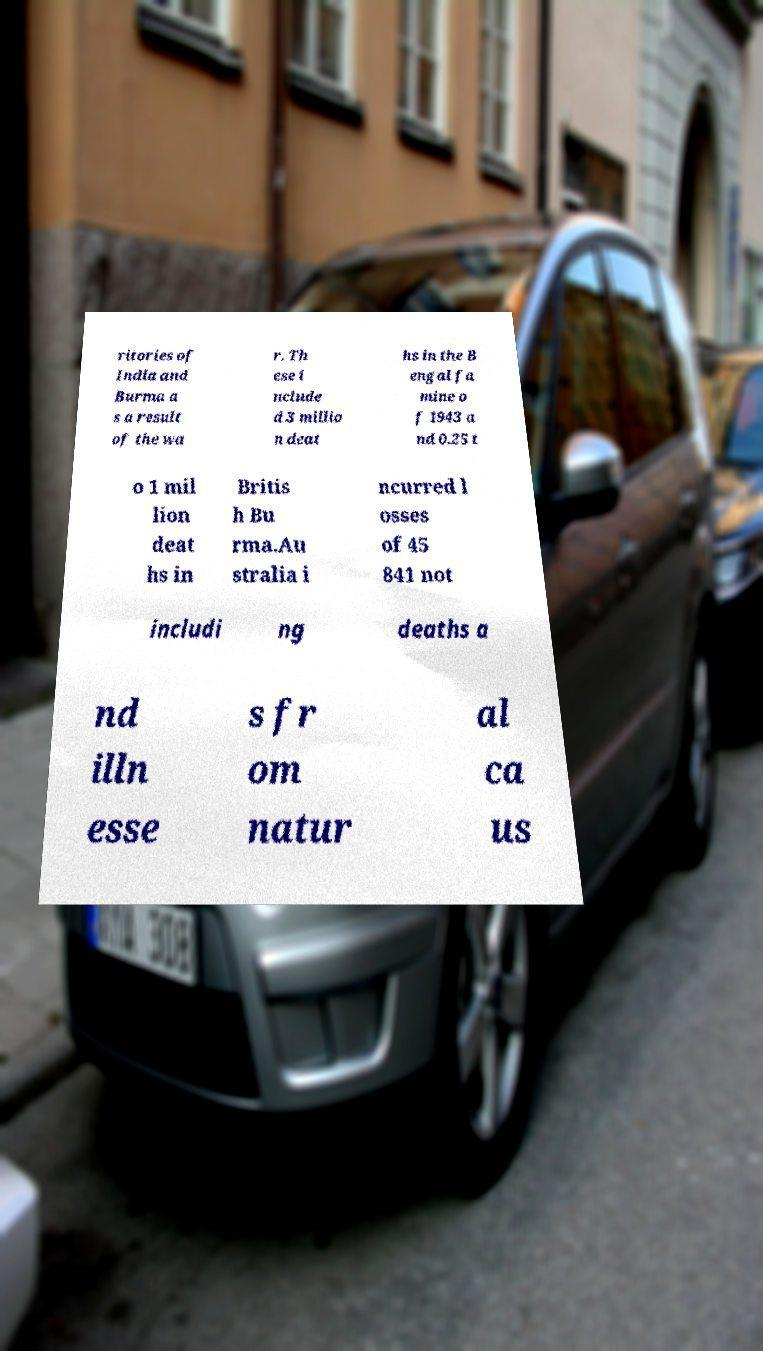Can you read and provide the text displayed in the image?This photo seems to have some interesting text. Can you extract and type it out for me? ritories of India and Burma a s a result of the wa r. Th ese i nclude d 3 millio n deat hs in the B engal fa mine o f 1943 a nd 0.25 t o 1 mil lion deat hs in Britis h Bu rma.Au stralia i ncurred l osses of 45 841 not includi ng deaths a nd illn esse s fr om natur al ca us 